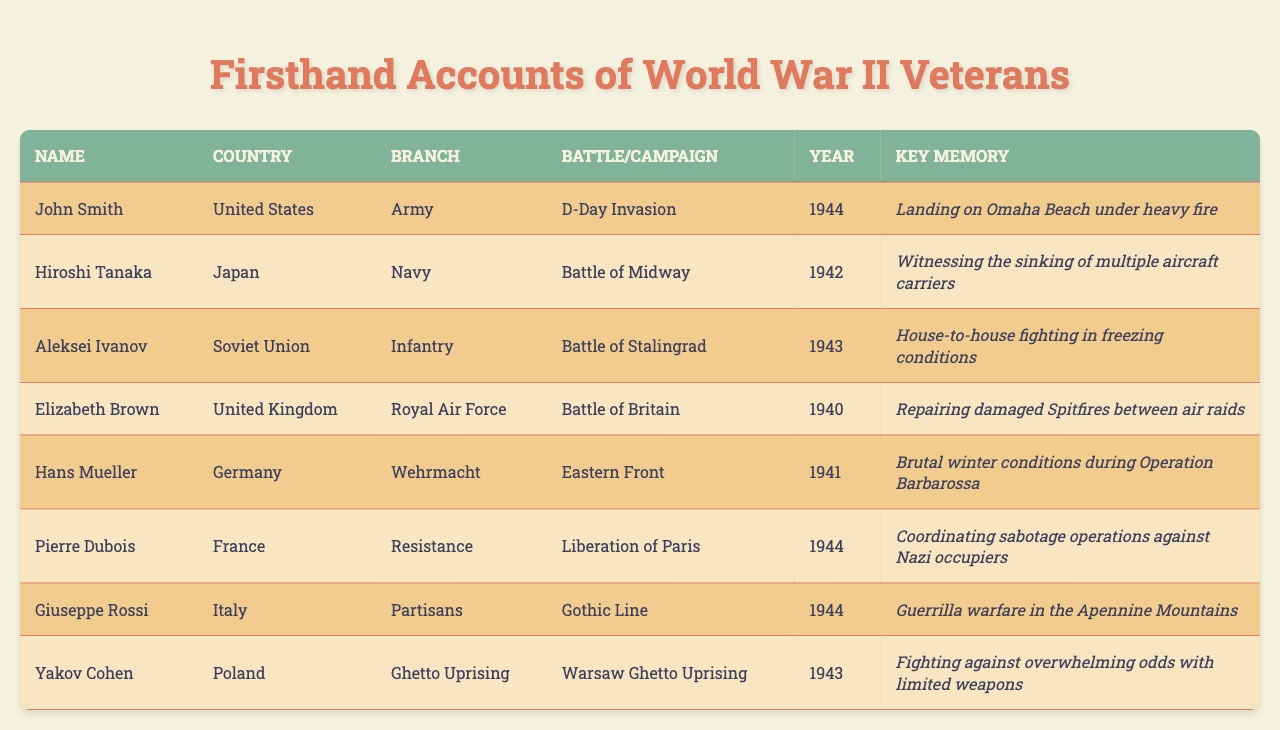What battle was John Smith involved in? John Smith's account lists "D-Day Invasion" under the "Battle/Campaign" column.
Answer: D-Day Invasion Which country did Aleksei Ivanov serve for? The "Country" column states that Aleksei Ivanov served for the "Soviet Union."
Answer: Soviet Union How many veterans' accounts are from the year 1944? By counting the entries, John Smith, Pierre Dubois, and Giuseppe Rossi are all listed for 1944, making a total of three accounts.
Answer: 3 Did Elizabeth Brown serve in the Air Force? The "Branch" column indicates that Elizabeth Brown was part of the "Royal Air Force."
Answer: Yes What was the key memory of Hans Mueller? The "Key Memory" for Hans Mueller describes "Brutal winter conditions during Operation Barbarossa."
Answer: Brutal winter conditions during Operation Barbarossa Which veteran's account mentions fighting in freezing conditions? Aleksei Ivanov's account refers to "House-to-house fighting in freezing conditions."
Answer: Aleksei Ivanov List the branches of the armed forces represented in the table. The "Branch" column includes Army, Navy, Infantry, Royal Air Force, Wehrmacht, Resistance, Partisans, and Ghetto Uprising, indicating diverse military services.
Answer: Army, Navy, Infantry, Royal Air Force, Wehrmacht, Resistance, Partisans, Ghetto Uprising Which veteran fought in the Eastern Front? The account of Hans Mueller specifies his service in the "Eastern Front."
Answer: Hans Mueller What is the earliest year mentioned in the veteran accounts? The earliest year found in the accounts is 1940, as noted next to Elizabeth Brown's entry.
Answer: 1940 Which veteran's account involves coordinating sabotage operations? Pierre Dubois mentions coordinating sabotage operations in his key memory.
Answer: Pierre Dubois Are there more veterans from the Allied or Axis powers? The accounts include four from the Allies (U.S., U.K., Soviet Union, France) and four from the Axis (Germany, Japan, Italy), thus they are equal.
Answer: Equal What was the focus of Yakov Cohen's experience? Yakov Cohen's account reflects on the "Warsaw Ghetto Uprising," indicating his focus during that event.
Answer: Warsaw Ghetto Uprising Which two veterans served in the same year? John Smith and Pierre Dubois both served in 1944, sharing that year in their accounts.
Answer: John Smith and Pierre Dubois What battle did Hiroshi Tanaka participate in? Hiroshi Tanaka's account specifically mentions the "Battle of Midway."
Answer: Battle of Midway What factor connects the veterans from the United States and the United Kingdom? Both served in campaigns related to the Western Front (D-Day and Battle of Britain).
Answer: Western Front connection 